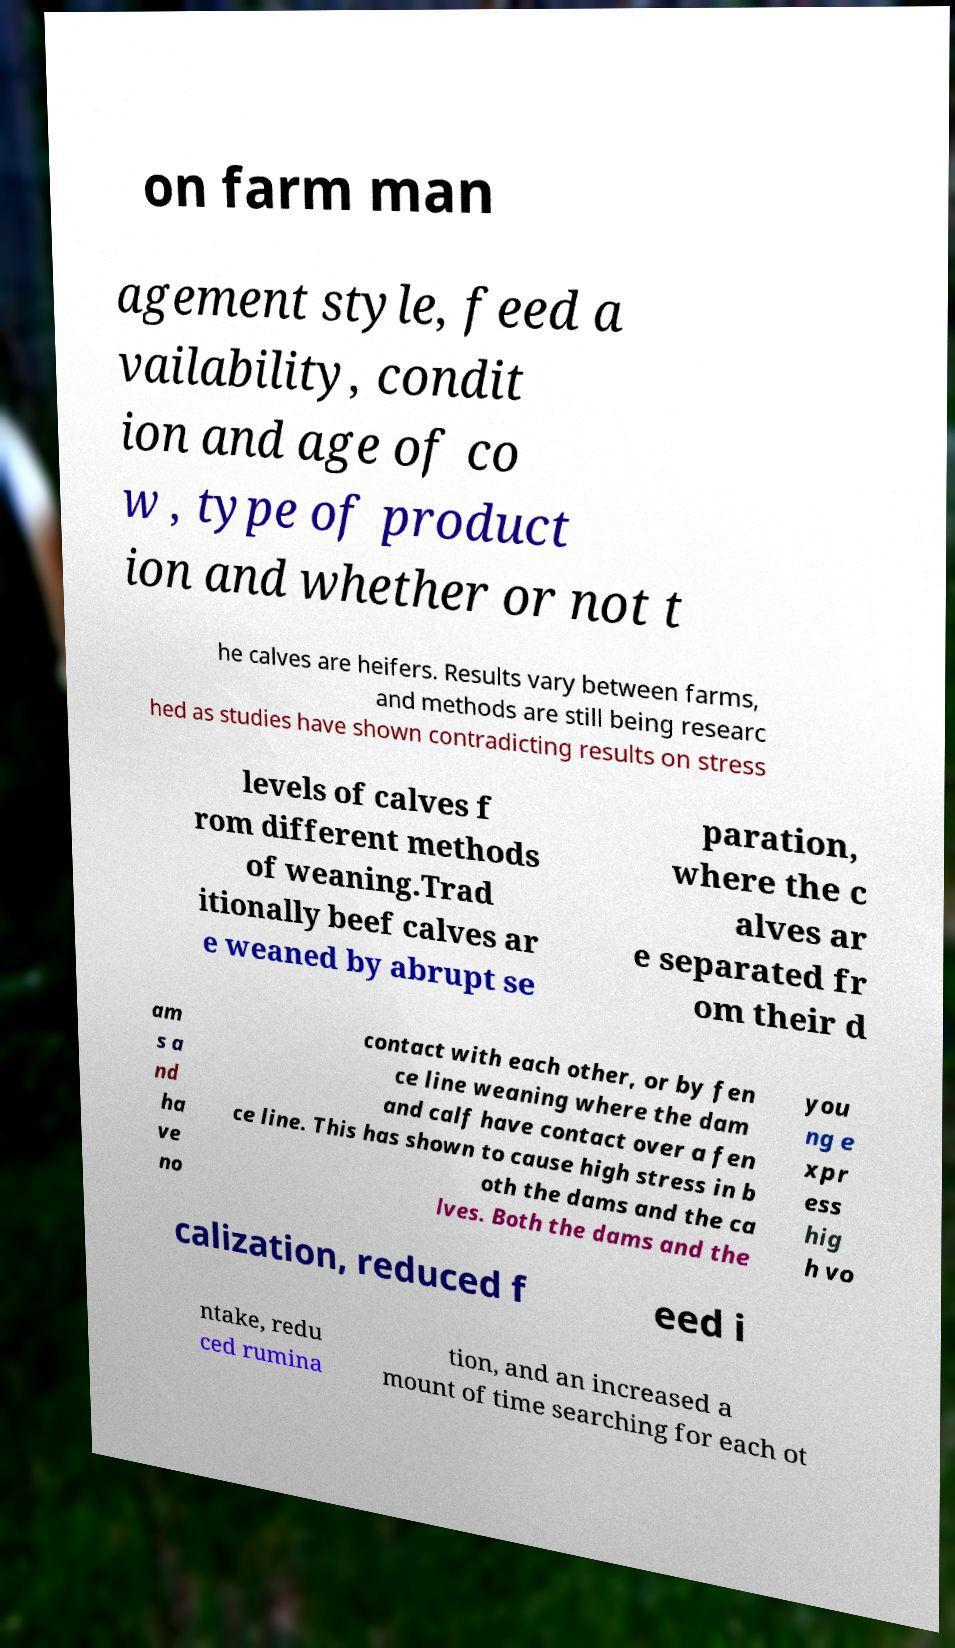Please read and relay the text visible in this image. What does it say? on farm man agement style, feed a vailability, condit ion and age of co w , type of product ion and whether or not t he calves are heifers. Results vary between farms, and methods are still being researc hed as studies have shown contradicting results on stress levels of calves f rom different methods of weaning.Trad itionally beef calves ar e weaned by abrupt se paration, where the c alves ar e separated fr om their d am s a nd ha ve no contact with each other, or by fen ce line weaning where the dam and calf have contact over a fen ce line. This has shown to cause high stress in b oth the dams and the ca lves. Both the dams and the you ng e xpr ess hig h vo calization, reduced f eed i ntake, redu ced rumina tion, and an increased a mount of time searching for each ot 